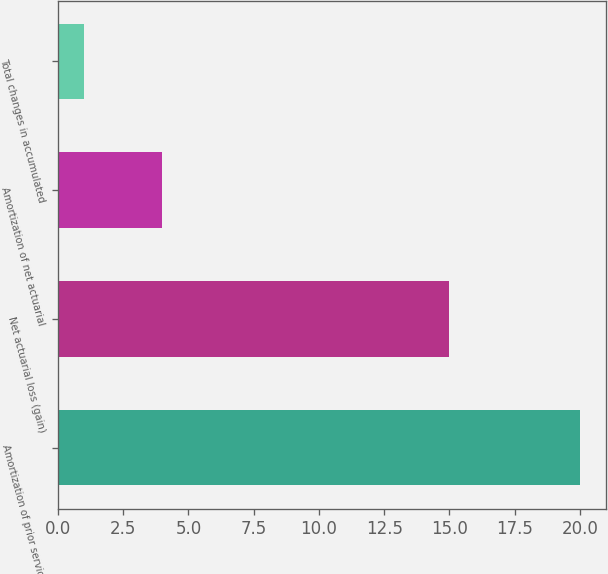<chart> <loc_0><loc_0><loc_500><loc_500><bar_chart><fcel>Amortization of prior service<fcel>Net actuarial loss (gain)<fcel>Amortization of net actuarial<fcel>Total changes in accumulated<nl><fcel>20<fcel>15<fcel>4<fcel>1<nl></chart> 